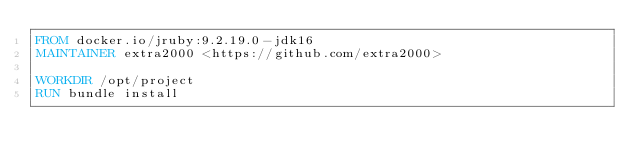<code> <loc_0><loc_0><loc_500><loc_500><_Dockerfile_>FROM docker.io/jruby:9.2.19.0-jdk16
MAINTAINER extra2000 <https://github.com/extra2000>

WORKDIR /opt/project
RUN bundle install
</code> 